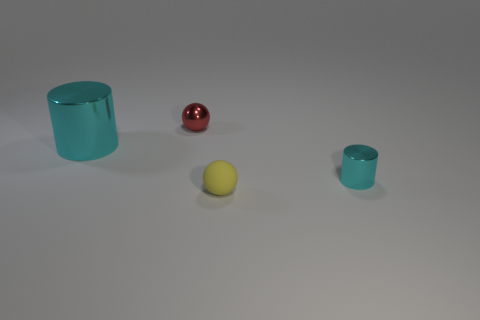There is a thing that is the same color as the small cylinder; what is its shape?
Your answer should be very brief. Cylinder. How many objects are either things that are to the right of the tiny yellow matte object or blue things?
Your answer should be very brief. 1. What size is the other cyan object that is the same material as the tiny cyan thing?
Offer a terse response. Large. Is the size of the yellow sphere the same as the ball that is behind the small cyan cylinder?
Offer a very short reply. Yes. There is a thing that is both on the left side of the tiny cyan thing and to the right of the small red metallic sphere; what is its color?
Offer a very short reply. Yellow. What number of objects are either cylinders in front of the large cyan object or tiny balls that are to the right of the red object?
Your answer should be very brief. 2. What color is the small ball that is in front of the cyan metal object right of the cyan cylinder that is behind the tiny cyan metal cylinder?
Keep it short and to the point. Yellow. Are there any small matte objects that have the same shape as the red metal object?
Provide a short and direct response. Yes. How many big gray rubber things are there?
Provide a succinct answer. 0. What is the shape of the red thing?
Offer a terse response. Sphere. 